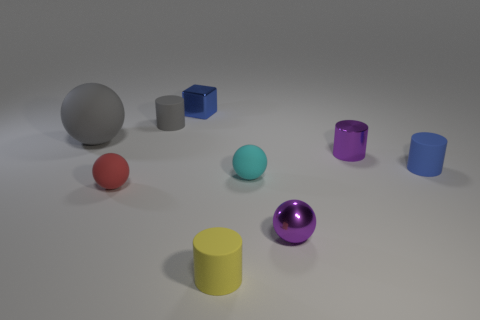Subtract 1 spheres. How many spheres are left? 3 Add 1 large cyan metal balls. How many objects exist? 10 Subtract all cylinders. How many objects are left? 5 Add 6 small red things. How many small red things exist? 7 Subtract 0 brown balls. How many objects are left? 9 Subtract all big yellow shiny balls. Subtract all small blue matte cylinders. How many objects are left? 8 Add 8 small gray matte objects. How many small gray matte objects are left? 9 